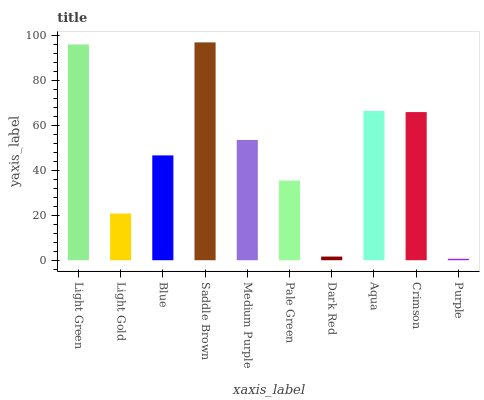Is Purple the minimum?
Answer yes or no. Yes. Is Saddle Brown the maximum?
Answer yes or no. Yes. Is Light Gold the minimum?
Answer yes or no. No. Is Light Gold the maximum?
Answer yes or no. No. Is Light Green greater than Light Gold?
Answer yes or no. Yes. Is Light Gold less than Light Green?
Answer yes or no. Yes. Is Light Gold greater than Light Green?
Answer yes or no. No. Is Light Green less than Light Gold?
Answer yes or no. No. Is Medium Purple the high median?
Answer yes or no. Yes. Is Blue the low median?
Answer yes or no. Yes. Is Light Gold the high median?
Answer yes or no. No. Is Light Gold the low median?
Answer yes or no. No. 